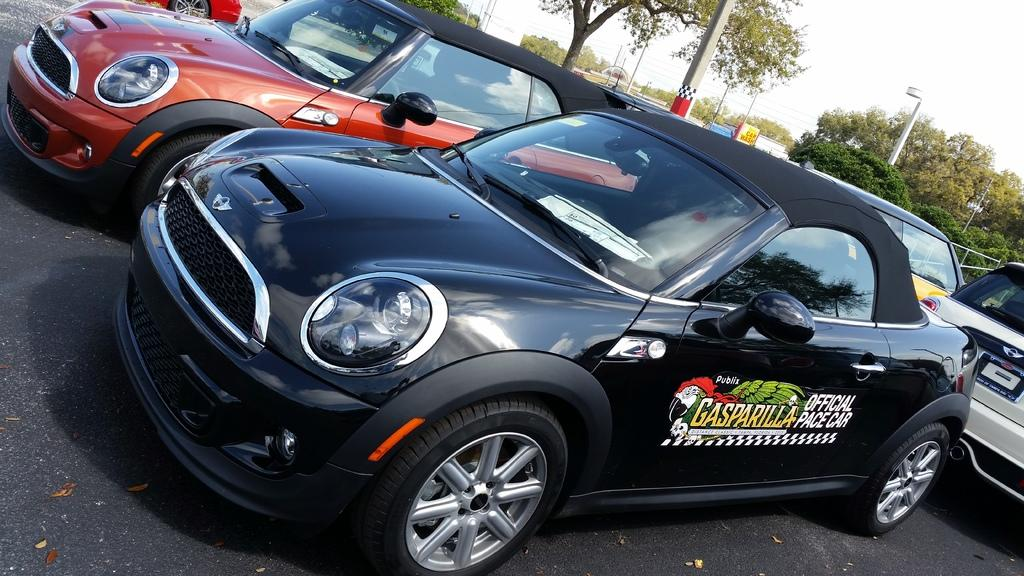What can be seen on the road in the image? There are vehicles on the road in the image. Can you describe the appearance of the vehicles? The vehicles are in different colors. What is visible in the background of the image? There are poles, trees, hoardings, and the sky visible in the background. What type of cast can be seen on the toad in the image? There is no toad or cast present in the image. What impulse might have caused the vehicles to move in the image? The image does not provide information about the impulse that caused the vehicles to move; it only shows them in their current positions. 